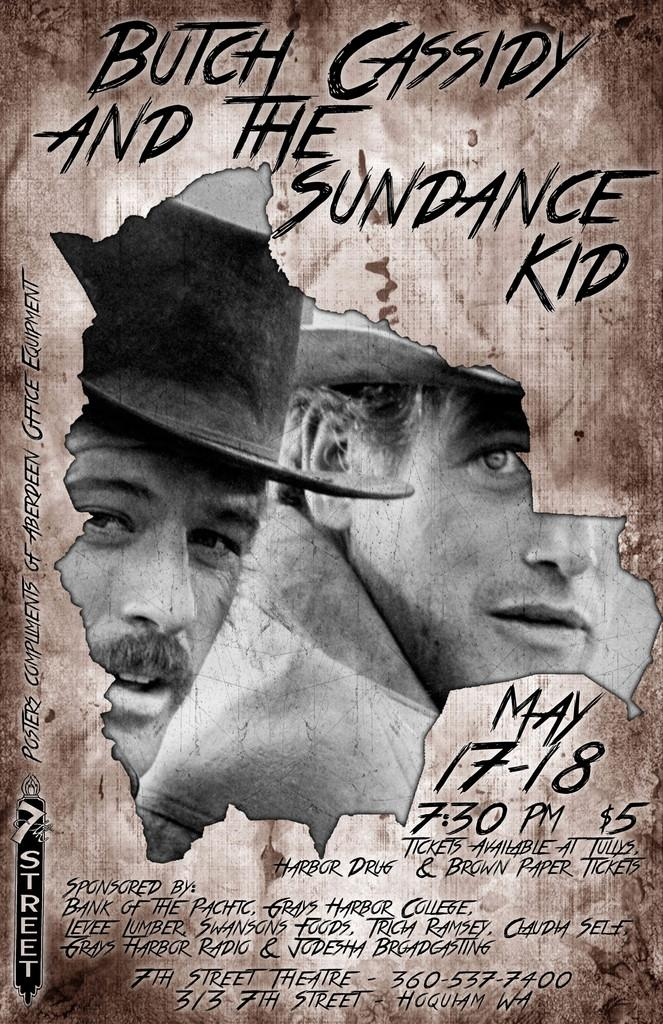What type of visual is the subject of the image? The image is a poster. What is depicted on the poster? There is an image on the poster. How many people are in the image? There are two persons in the image. What are the persons wearing on their heads? The persons are wearing caps. What is the facial expression of the persons in the image? The persons are smiling. How does the poster compare to a swimming pool in the image? There is no swimming pool present in the image; it is a poster featuring two persons wearing caps and smiling. 